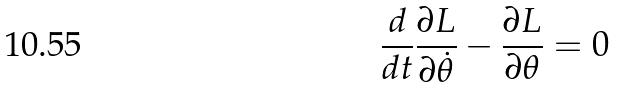Convert formula to latex. <formula><loc_0><loc_0><loc_500><loc_500>\frac { d } { d t } \frac { \partial L } { \partial \dot { \theta } } - \frac { \partial L } { \partial \theta } = 0</formula> 